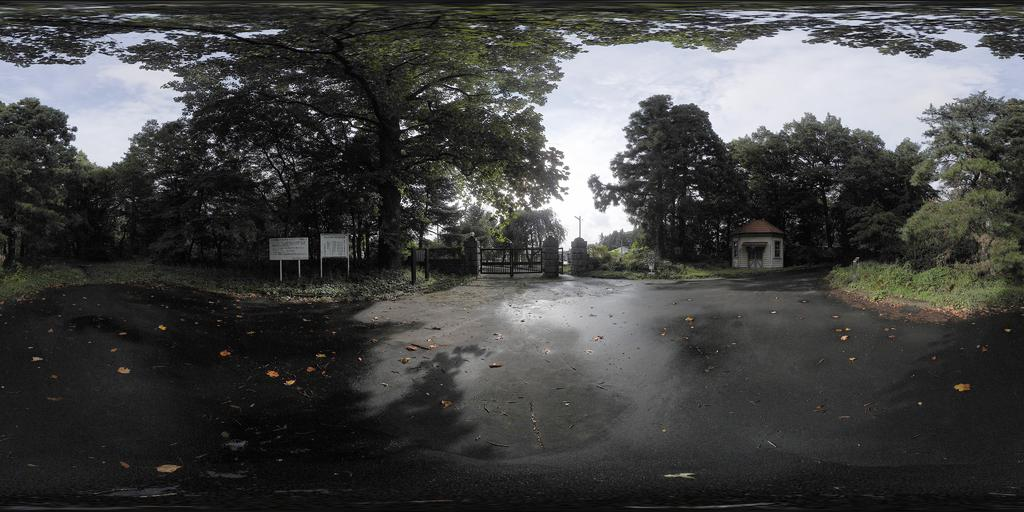What is in the foreground of the image? There is a road in the foreground of the image. What can be seen in the background of the image? There are trees, poles, a house structure, a gate, and the sky visible in the background of the image. What type of vegetation is present in the background of the image? There are trees in the background of the image. What architectural feature is present in the background of the image? There is a house structure in the background of the image. What type of sack is being carried by the tree in the image? There are no sacks or trees carrying anything in the image. What color are the lips of the person in the image? There are no people or lips visible in the image. 